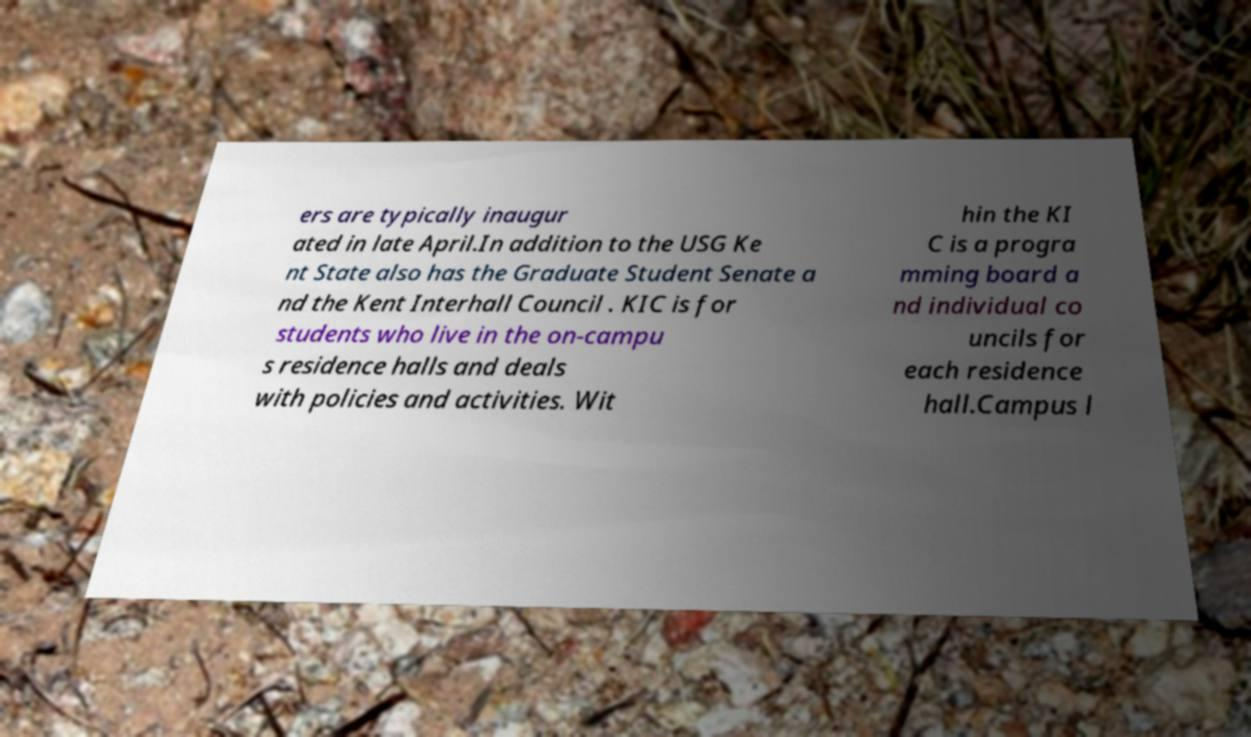I need the written content from this picture converted into text. Can you do that? ers are typically inaugur ated in late April.In addition to the USG Ke nt State also has the Graduate Student Senate a nd the Kent Interhall Council . KIC is for students who live in the on-campu s residence halls and deals with policies and activities. Wit hin the KI C is a progra mming board a nd individual co uncils for each residence hall.Campus l 